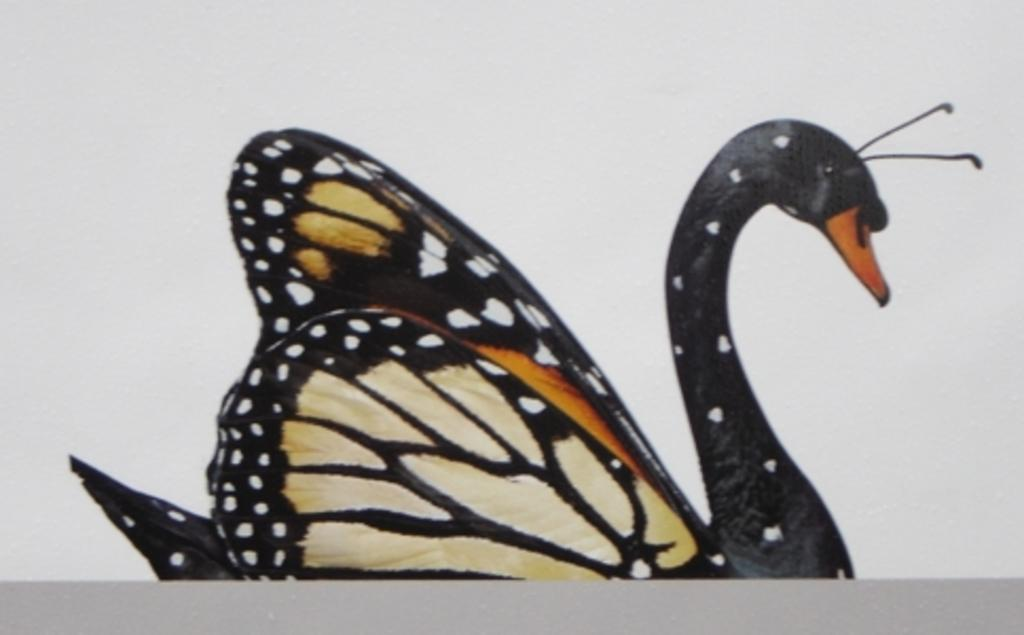What is the main subject in the foreground of the image? There is a poster in the foreground of the image. What is depicted on the poster? The poster features butterfly wings on a duck. What color is the background of the poster? The background of the poster is white. What type of error can be seen in the lumber industry in the image? There is no reference to the lumber industry or any errors in the image; it features a poster with a duck and butterfly wings. 